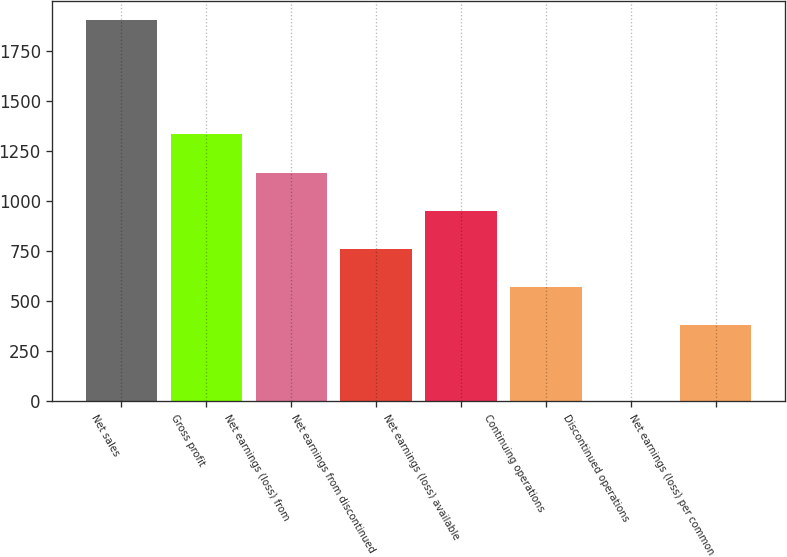Convert chart. <chart><loc_0><loc_0><loc_500><loc_500><bar_chart><fcel>Net sales<fcel>Gross profit<fcel>Net earnings (loss) from<fcel>Net earnings from discontinued<fcel>Net earnings (loss) available<fcel>Continuing operations<fcel>Discontinued operations<fcel>Net earnings (loss) per common<nl><fcel>1901.9<fcel>1331.37<fcel>1141.18<fcel>760.81<fcel>951<fcel>570.62<fcel>0.05<fcel>380.43<nl></chart> 